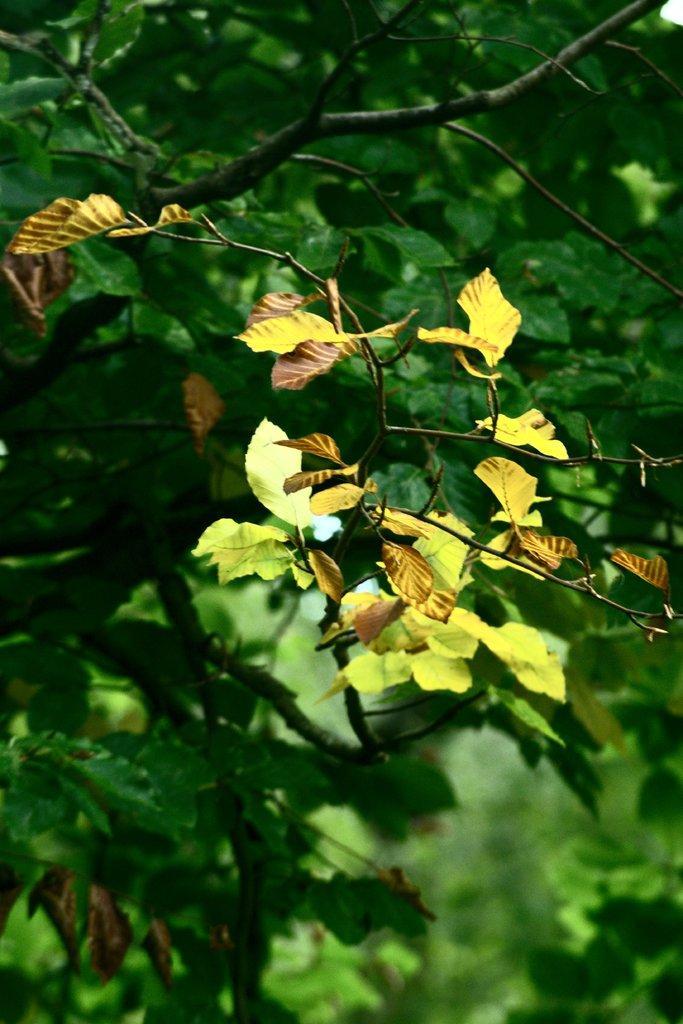Can you describe this image briefly? We can see yellow and green leaves and we can see stems. 